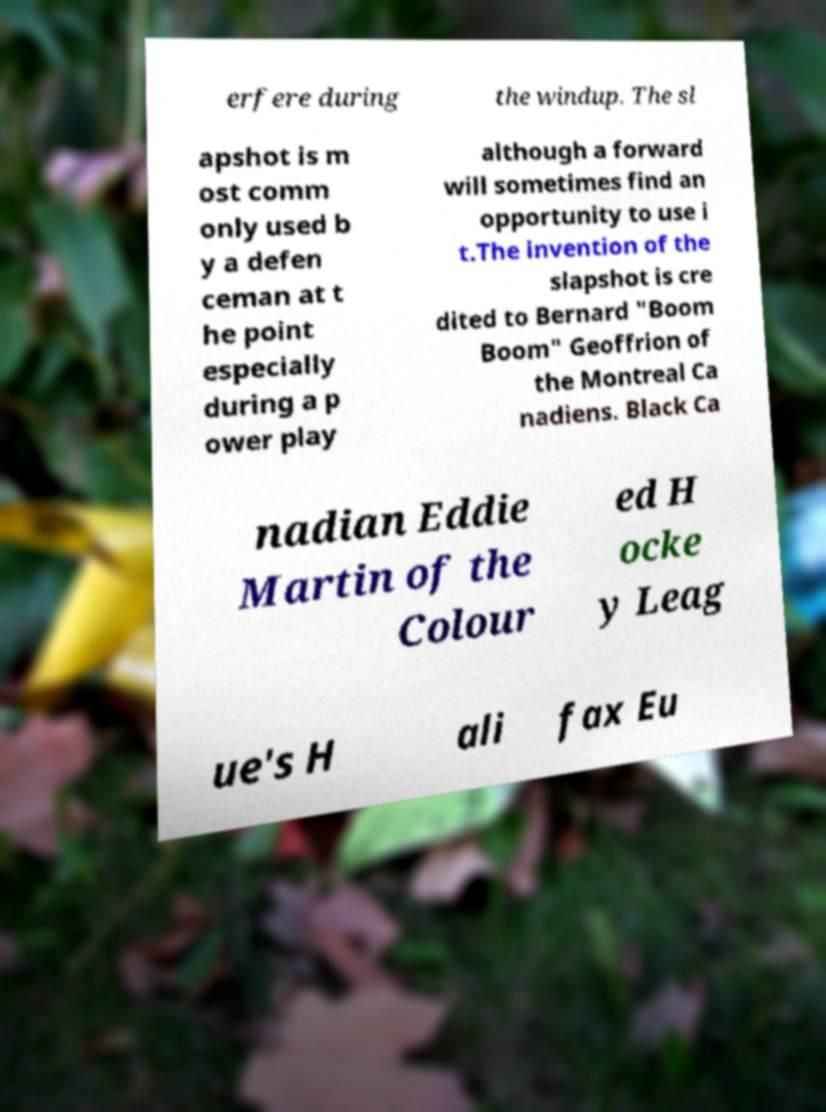There's text embedded in this image that I need extracted. Can you transcribe it verbatim? erfere during the windup. The sl apshot is m ost comm only used b y a defen ceman at t he point especially during a p ower play although a forward will sometimes find an opportunity to use i t.The invention of the slapshot is cre dited to Bernard "Boom Boom" Geoffrion of the Montreal Ca nadiens. Black Ca nadian Eddie Martin of the Colour ed H ocke y Leag ue's H ali fax Eu 